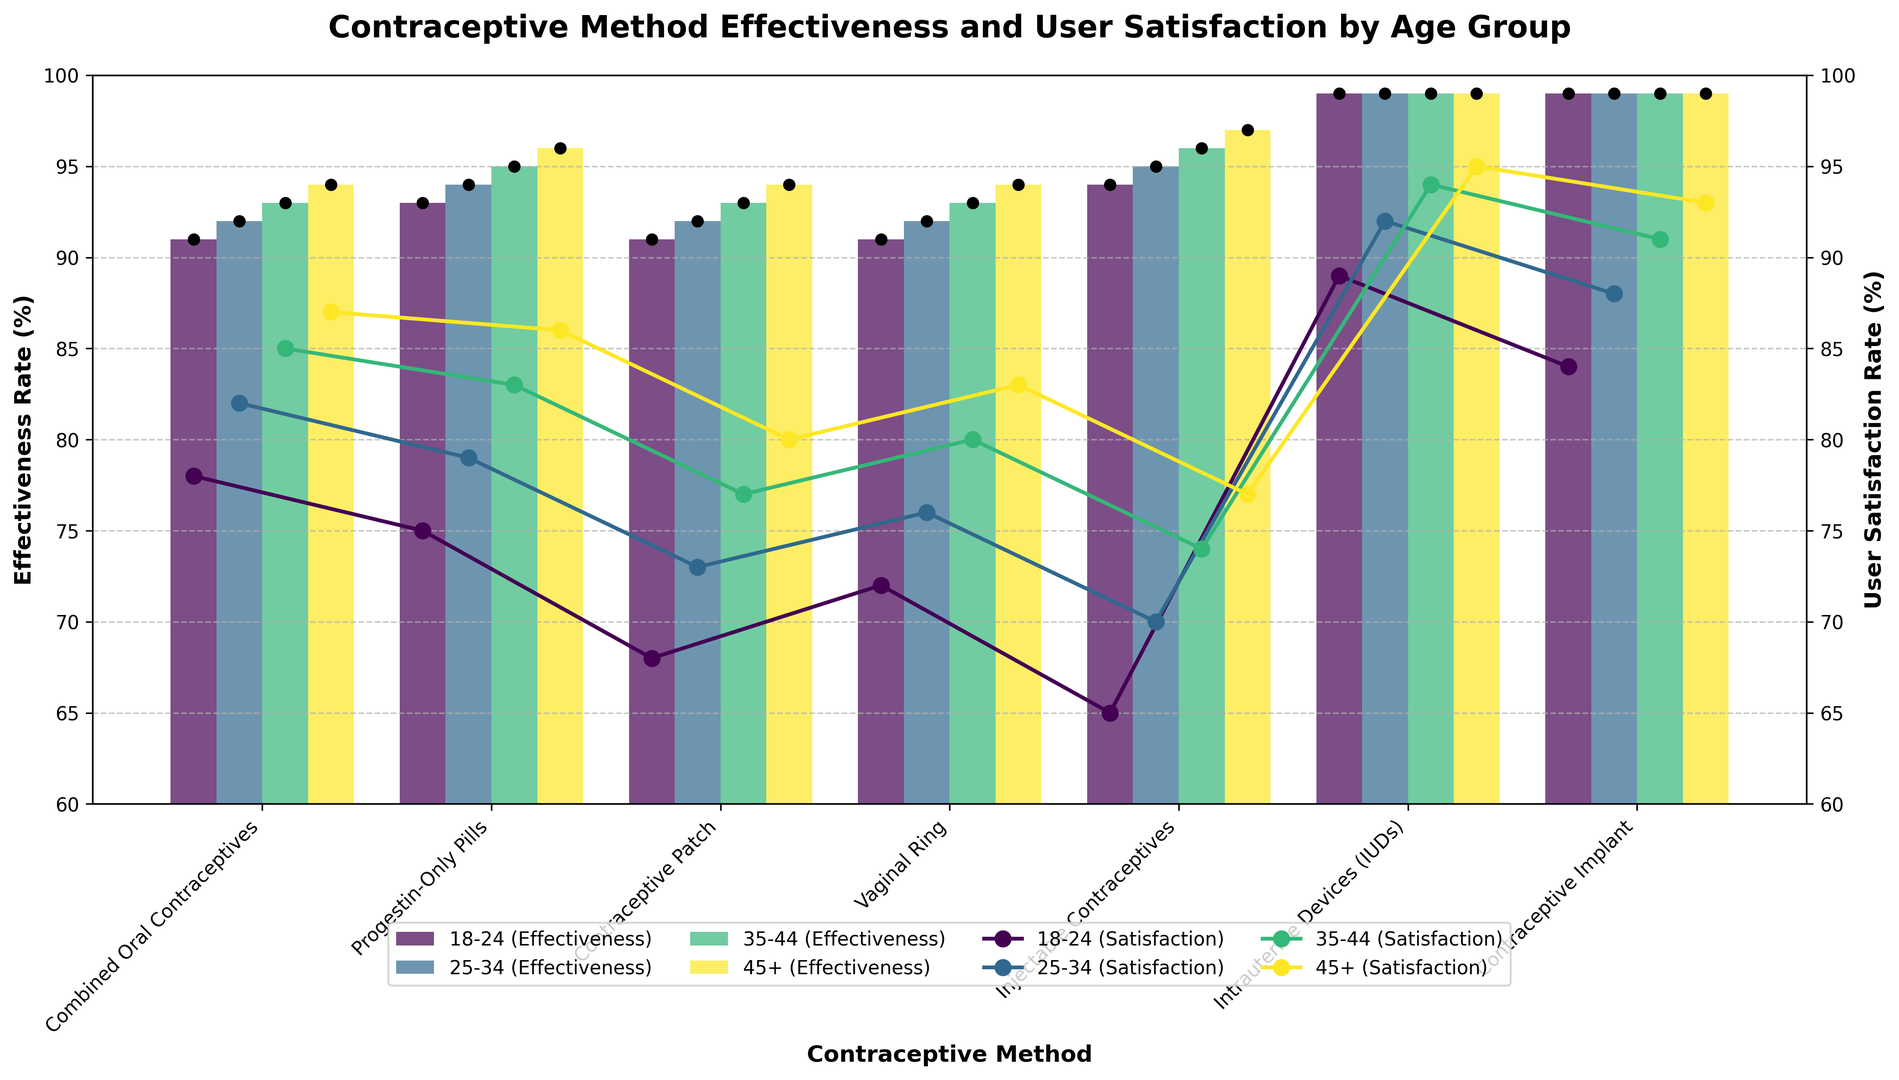What are the highest and lowest user satisfaction rates among women aged 18-24, and which methods do they correspond to? To find the highest and lowest satisfaction rates for women aged 18-24, we look at the different satisfaction rates within that age group. The highest satisfaction is 89%, corresponding to IUDs, and the lowest is 65%, corresponding to Injectable Contraceptives.
Answer: Highest: 89% (IUDs), Lowest: 65% (Injectable Contraceptives) How does the user satisfaction rate for Combined Oral Contraceptives change with age? The satisfaction rate for Combined Oral Contraceptives increases with age: it is 78% for ages 18-24, 82% for ages 25-34, 85% for ages 35-44, and 87% for ages 45+.
Answer: Increases with age Which age group shows the highest satisfaction with the Contraceptive Implant? The satisfaction rates for the Contraceptive Implant are highest among women aged 45+ at 93%, 18-24 at 84%, 25-34 at 88%, and 35-44 at 91%. The highest satisfaction is seen in the 45+ age group.
Answer: 45+ What is the effectiveness rate range for Injectable Contraceptives across all age groups? The effectiveness rates for Injectable Contraceptives are 94% for ages 18-24, 95% for ages 25-34, 96% for ages 35-44, and 97% for ages 45+. The range is from 94% to 97%.
Answer: 94%-97% What are the differences in satisfaction rates between the Contraceptive Patch and the Vaginal Ring for women aged 18-24? For women aged 18-24, the satisfaction rate for the Contraceptive Patch is 68%, while for the Vaginal Ring, it is 72%. The difference is 72% - 68% = 4%.
Answer: 4% Among women aged 25-34, which contraceptive methods have the same effectiveness rate? In the 25-34 age group, Combined Oral Contraceptives, Progestin-Only Pills, Contraceptive Patch, and Vaginal Ring each have an effectiveness rate of 92%.
Answer: Combined Oral Contraceptives, Progestin-Only Pills, Contraceptive Patch, Vaginal Ring Which age group has the smallest difference between effectiveness and satisfaction rates for IUDs? By comparing the difference between effectiveness and satisfaction rates for IUDs: 18-24 (10%), 25-34 (7%), 35-44 (5%), and 45+ (4%). The 45+ age group has the smallest difference at 4%.
Answer: 45+ What is the combined average user satisfaction rate for Progestin-Only Pills for the age groups 25-34 and 35-44? Satisfaction rates for Progestin-Only Pills are 79% for ages 25-34 and 83% for ages 35-44. The average is (79 + 83) / 2 = 81%.
Answer: 81% Are there any contraceptive methods where the satisfaction rate is consistently above 75% across all age groups? By examining the user satisfaction rates: Combined Oral Contraceptives and Progestin-Only Pills have satisfaction rates consistently above 75% in all age groups.
Answer: Combined Oral Contraceptives, Progestin-Only Pills 